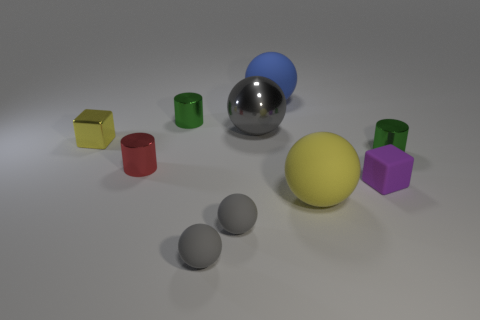There is a matte cube that is the same size as the red shiny cylinder; what is its color?
Provide a succinct answer. Purple. There is a green metal cylinder left of the large metal object; are there any cylinders right of it?
Your answer should be compact. Yes. There is a tiny thing that is to the right of the small purple matte object; what is it made of?
Provide a succinct answer. Metal. Does the big object that is to the right of the blue matte thing have the same material as the thing that is to the right of the purple matte block?
Your response must be concise. No. Is the number of yellow metallic objects behind the large blue rubber sphere the same as the number of small red objects that are to the left of the small purple block?
Your answer should be compact. No. How many blue objects have the same material as the large yellow object?
Your answer should be very brief. 1. What shape is the thing that is the same color as the tiny shiny cube?
Keep it short and to the point. Sphere. There is a yellow ball in front of the cylinder that is to the right of the purple cube; what size is it?
Provide a short and direct response. Large. There is a green shiny object that is left of the big gray metallic ball; does it have the same shape as the small green thing in front of the tiny metallic cube?
Give a very brief answer. Yes. Are there the same number of purple rubber blocks behind the blue ball and large yellow shiny spheres?
Your answer should be very brief. Yes. 